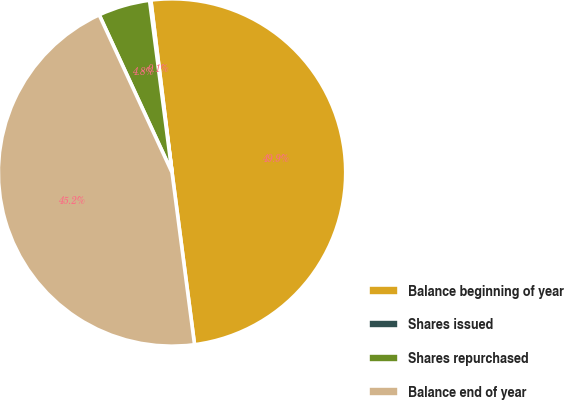Convert chart to OTSL. <chart><loc_0><loc_0><loc_500><loc_500><pie_chart><fcel>Balance beginning of year<fcel>Shares issued<fcel>Shares repurchased<fcel>Balance end of year<nl><fcel>49.88%<fcel>0.12%<fcel>4.82%<fcel>45.18%<nl></chart> 